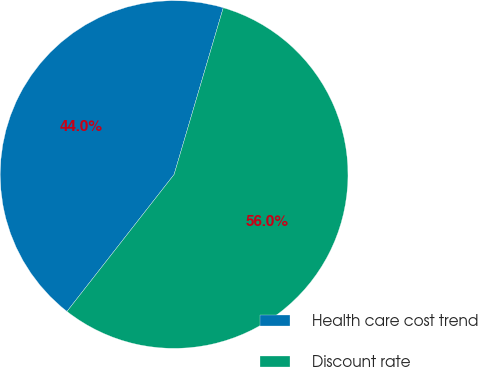<chart> <loc_0><loc_0><loc_500><loc_500><pie_chart><fcel>Health care cost trend<fcel>Discount rate<nl><fcel>44.0%<fcel>56.0%<nl></chart> 